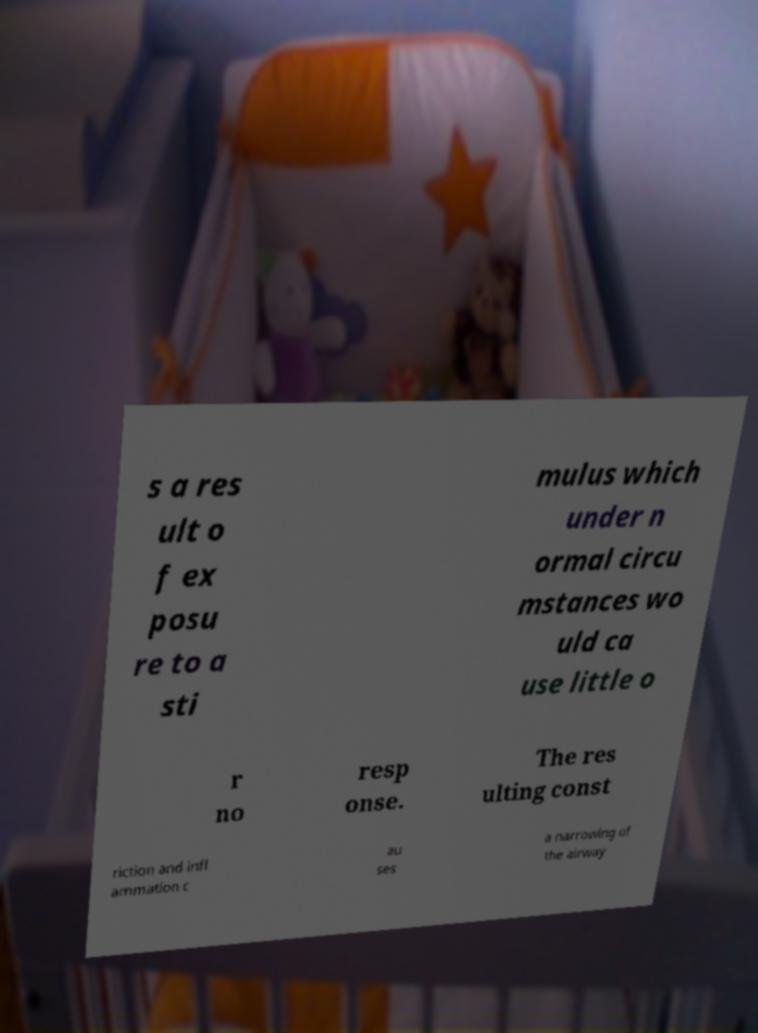Please read and relay the text visible in this image. What does it say? s a res ult o f ex posu re to a sti mulus which under n ormal circu mstances wo uld ca use little o r no resp onse. The res ulting const riction and infl ammation c au ses a narrowing of the airway 